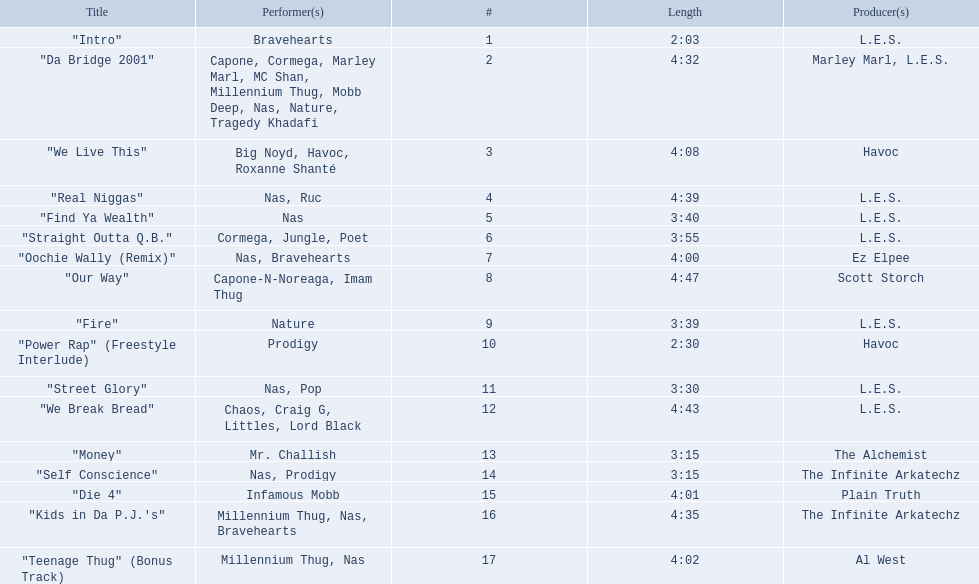How long is each song? 2:03, 4:32, 4:08, 4:39, 3:40, 3:55, 4:00, 4:47, 3:39, 2:30, 3:30, 4:43, 3:15, 3:15, 4:01, 4:35, 4:02. What length is the longest? 4:47. 